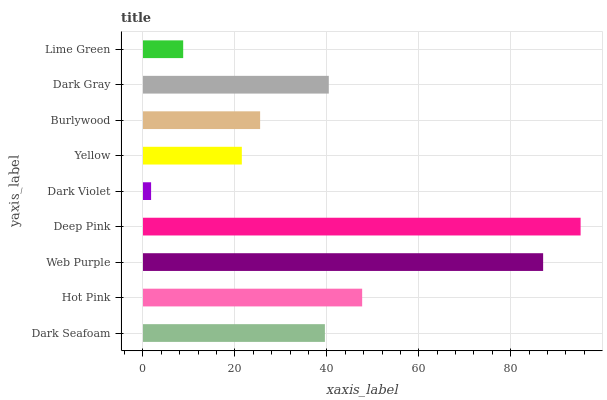Is Dark Violet the minimum?
Answer yes or no. Yes. Is Deep Pink the maximum?
Answer yes or no. Yes. Is Hot Pink the minimum?
Answer yes or no. No. Is Hot Pink the maximum?
Answer yes or no. No. Is Hot Pink greater than Dark Seafoam?
Answer yes or no. Yes. Is Dark Seafoam less than Hot Pink?
Answer yes or no. Yes. Is Dark Seafoam greater than Hot Pink?
Answer yes or no. No. Is Hot Pink less than Dark Seafoam?
Answer yes or no. No. Is Dark Seafoam the high median?
Answer yes or no. Yes. Is Dark Seafoam the low median?
Answer yes or no. Yes. Is Hot Pink the high median?
Answer yes or no. No. Is Burlywood the low median?
Answer yes or no. No. 